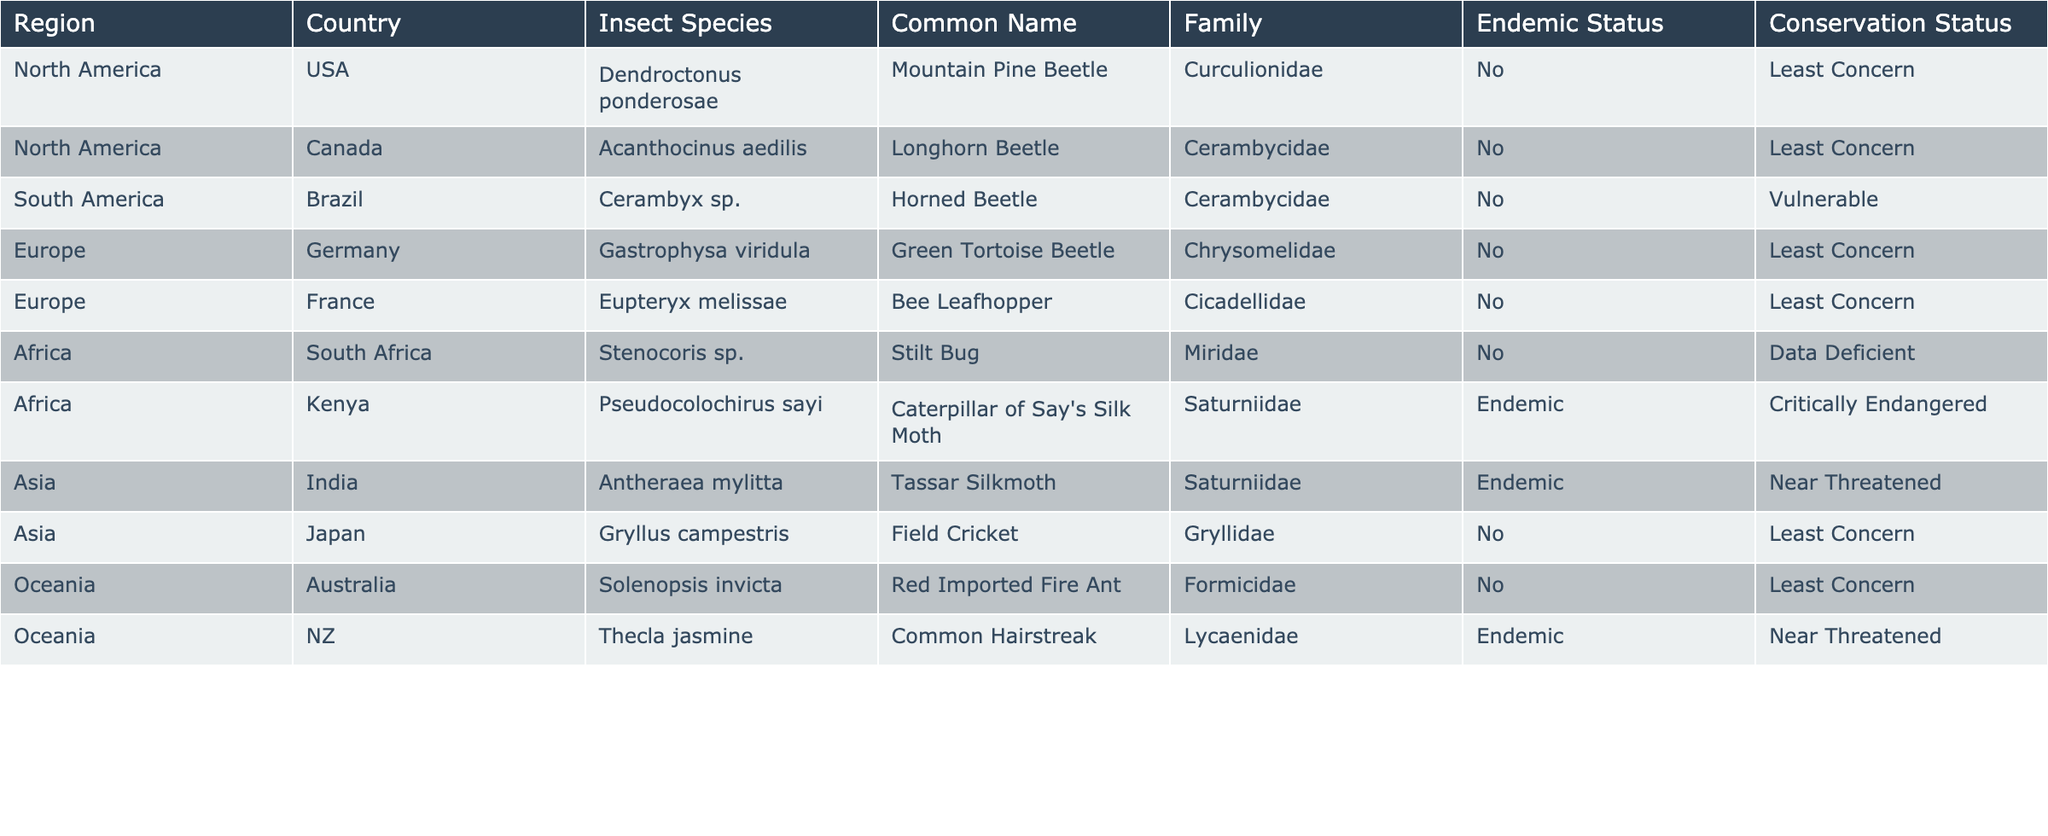What are the common names of the insects listed under the Asia region? In the Asia region, the table lists two insects: Antheraea mylitta, which is the Tassar Silkmoth, and Gryllus campestris, known as the Field Cricket.
Answer: Tassar Silkmoth, Field Cricket How many endemic insect species are recorded in this table? The table indicates that there are two endemic insect species: Pseudocolochirus sayi from Kenya and Thecla jasmine from New Zealand. Both entries have 'Endemic' under the Endemic Status column.
Answer: 2 Which insect from South America has a Vulnerable conservation status? In the table, the insect from South America is Cerambyx sp., and it is listed with a conservation status of Vulnerable.
Answer: Cerambyx sp Are there any insect species that are both endemic and critically endangered? Yes, the table shows one insect, Pseudocolochirus sayi from Kenya, which is listed as endemic and has a conservation status of Critically Endangered.
Answer: Yes What is the only insect listed as Data Deficient in Africa? The Data Deficient status applies to the Stenocoris sp. listed from South Africa.
Answer: Stenocoris sp How does the conservation status of endemic insects compare to non-endemic insects in the table? The two endemic insects (Pseudocolochirus sayi and Thecla jasmine) have a conservation status of Critically Endangered and Near Threatened, respectively. In contrast, non-endemic insects include multiple species with a status of Least Concern or Vulnerable, indicating that endemic species are generally at greater risk.
Answer: Endemic insects are at greater risk Which region contains the highest number of insect species recorded in the table? By counting the insect species listed under each region, we can see that North America, South America, Europe, Africa, Asia, and Oceania are represented, with each having one entry except for North America, which has two entries, indicating it has the most species listed.
Answer: North America Is the Mountain Pine Beetle endemic to North America? The Mountain Pine Beetle, or Dendroctonus ponderosae, is noted as not endemic (No) under the Endemic Status column, so it is not endemic to North America.
Answer: No What is the common name of the insect from Germany? The insect from Germany is Gastrophysa viridula, which is commonly known as the Green Tortoise Beetle.
Answer: Green Tortoise Beetle How many insects in the table are classified as Least Concern? There are six insects classified as Least Concern: Dendroctonus ponderosae, Acanthocinus aedilis, Gastrophysa viridula, Eupteryx melissae, Gryllus campestris, and Solenopsis invicta.
Answer: 6 What is the conservation status of the Longhorn Beetle from Canada? The Longhorn Beetle, known as Acanthocinus aedilis from Canada, has a conservation status of Least Concern.
Answer: Least Concern 